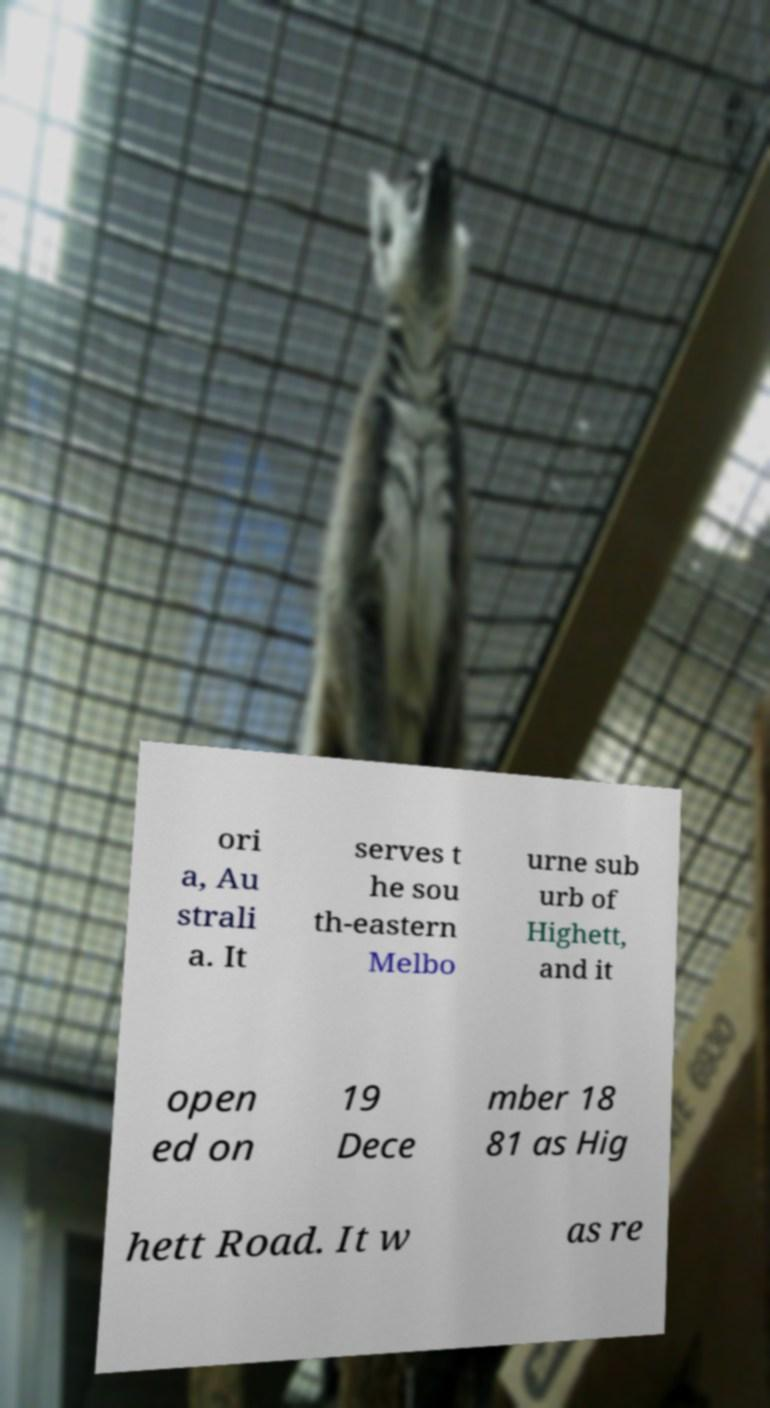Please read and relay the text visible in this image. What does it say? ori a, Au strali a. It serves t he sou th-eastern Melbo urne sub urb of Highett, and it open ed on 19 Dece mber 18 81 as Hig hett Road. It w as re 